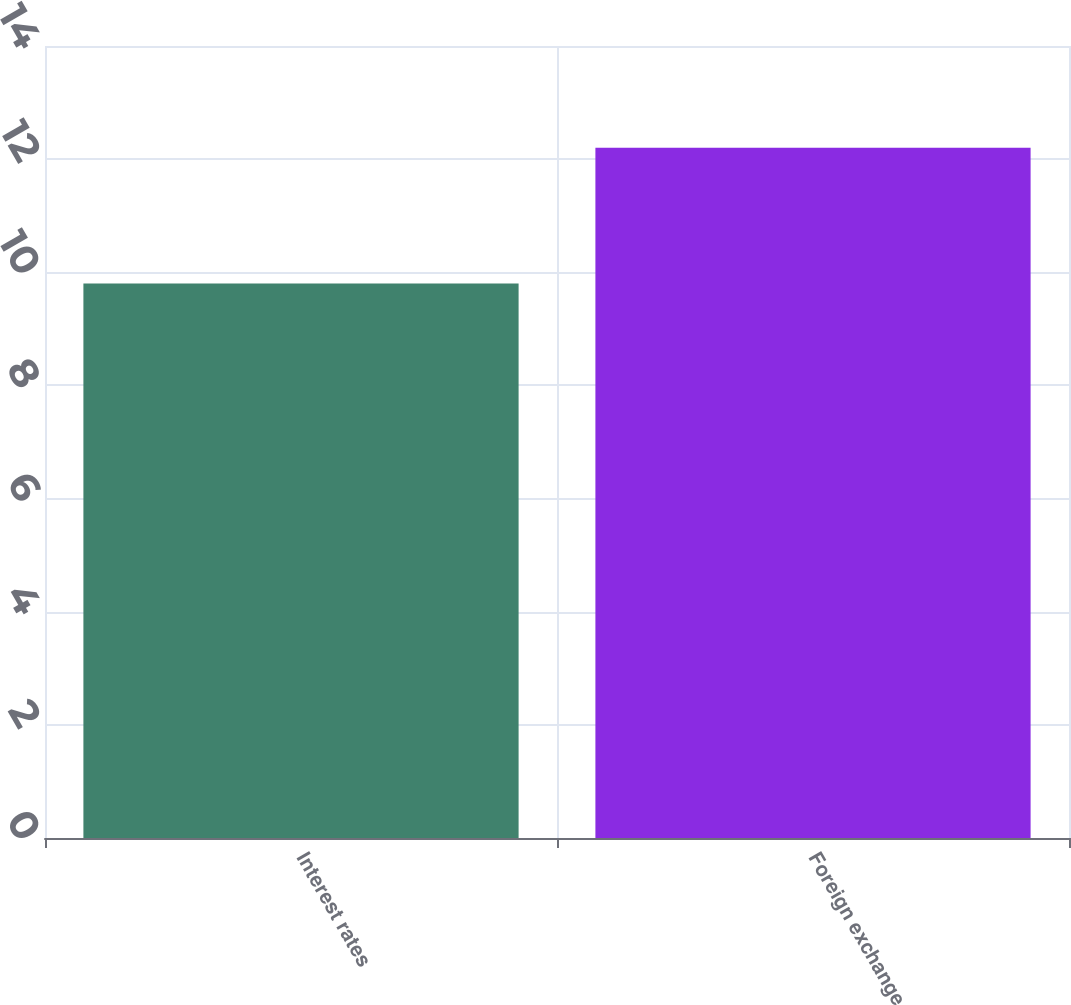<chart> <loc_0><loc_0><loc_500><loc_500><bar_chart><fcel>Interest rates<fcel>Foreign exchange<nl><fcel>9.8<fcel>12.2<nl></chart> 